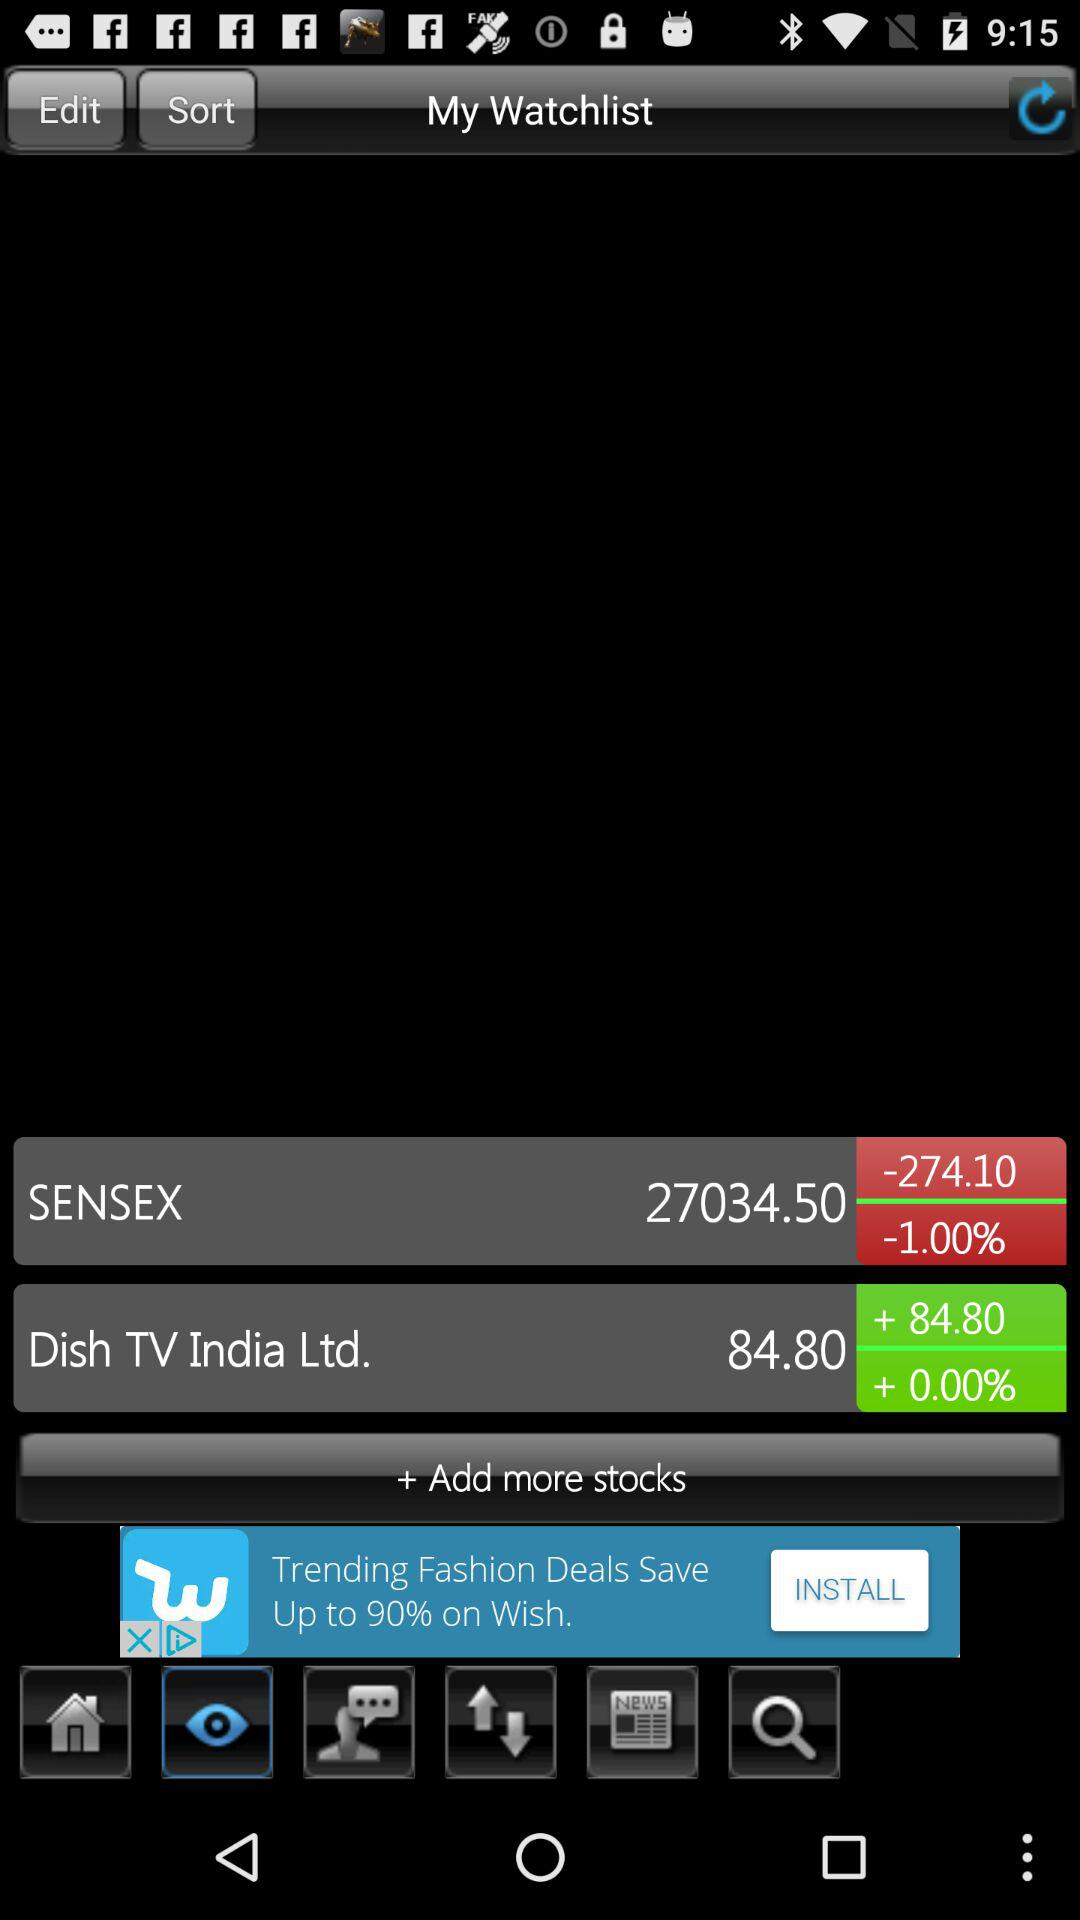What is the stock price of the SENSEX? The stock price is 27034.50. 